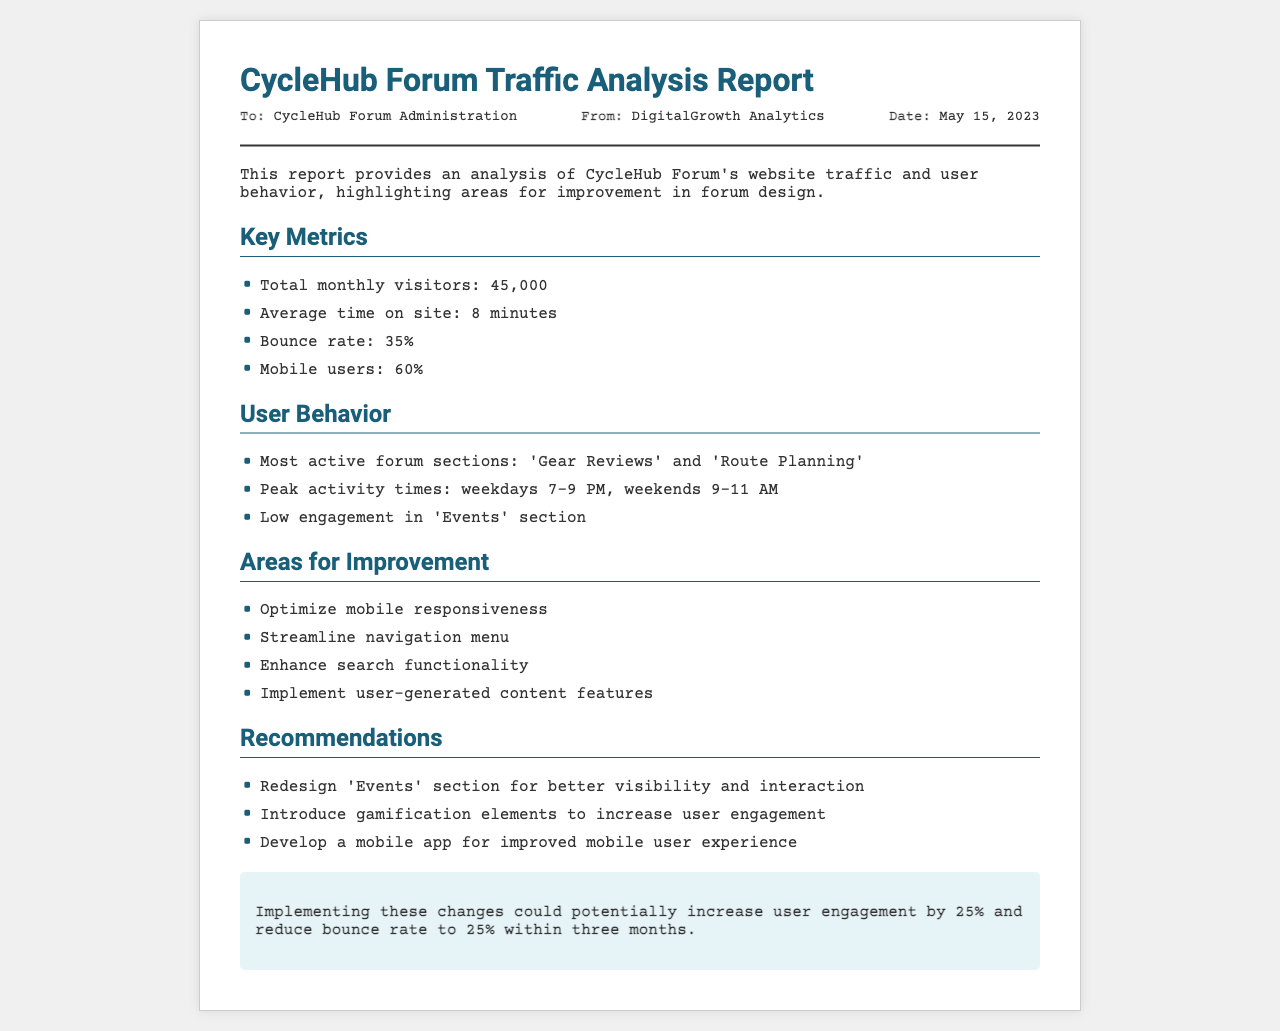What is the total monthly visitors? The total monthly visitors is listed in the key metrics section of the report as 45,000.
Answer: 45,000 What is the average time on site? The average time users spend on the site is mentioned in the key metrics section as 8 minutes.
Answer: 8 minutes What section has low engagement? The report indicates that the 'Events' section has low engagement in the user behavior section.
Answer: Events What is the bounce rate? The bounce rate is provided in the key metrics section as 35%.
Answer: 35% When are peak activity times during weekdays? The peak activity times for weekdays are specified in the user behavior section as 7-9 PM.
Answer: 7-9 PM What is one recommended improvement for the 'Events' section? The report recommends redesigning the 'Events' section for better visibility and interaction.
Answer: Redesign How much could user engagement potentially increase by implementing changes? The potential increase in user engagement is stated in the conclusion as 25%.
Answer: 25% What percentage of users are on mobile? The percentage of mobile users is mentioned in the key metrics section as 60%.
Answer: 60% What type of document is this? This document is a Traffic Analysis Report for the CycleHub Forum.
Answer: Traffic Analysis Report 